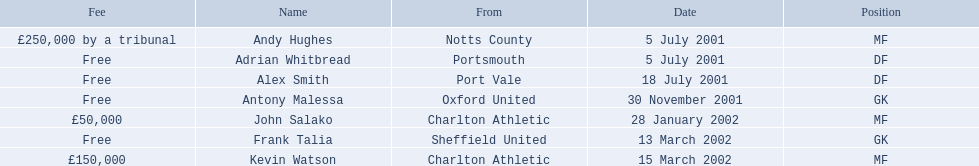List all the players names Andy Hughes, Adrian Whitbread, Alex Smith, Antony Malessa, John Salako, Frank Talia, Kevin Watson. Of these who is kevin watson Kevin Watson. To what transfer fee entry does kevin correspond to? £150,000. 